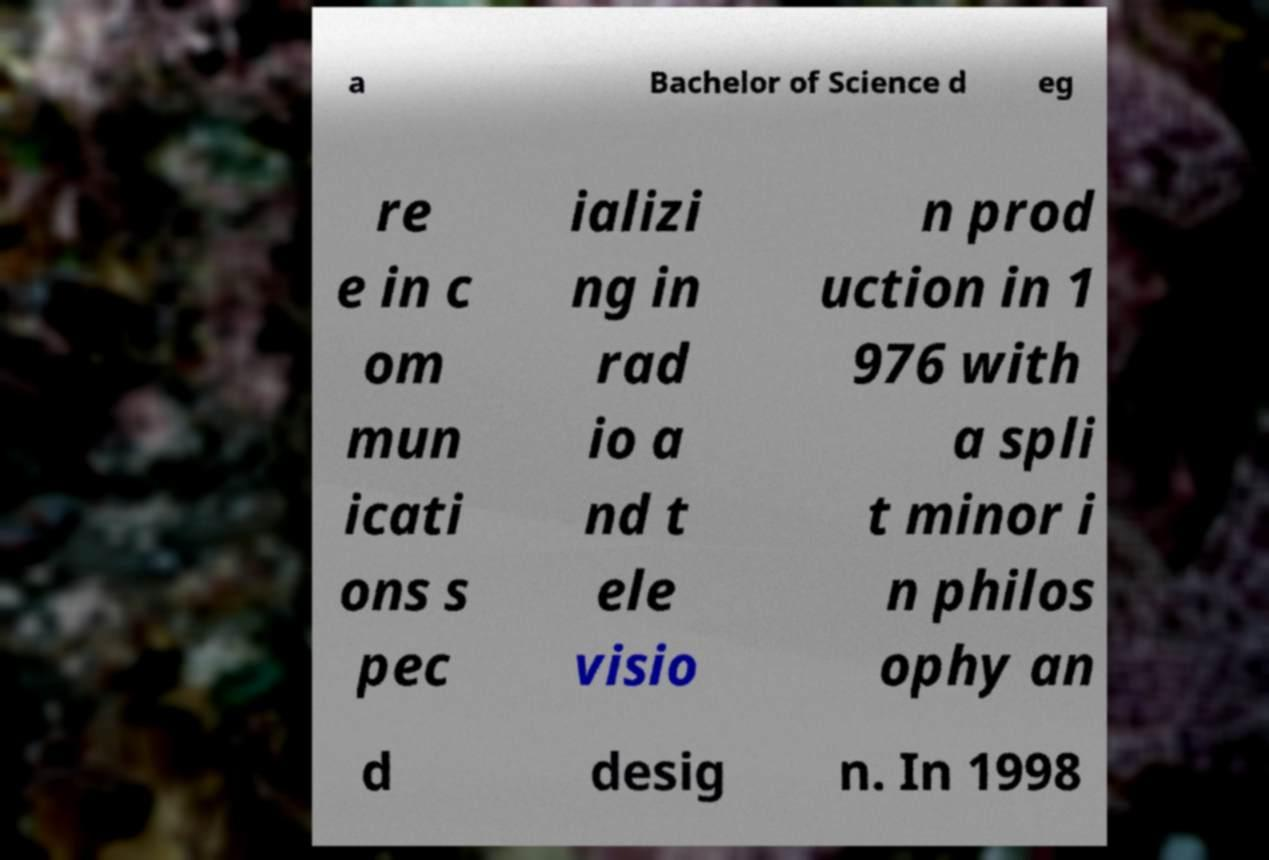Can you read and provide the text displayed in the image?This photo seems to have some interesting text. Can you extract and type it out for me? a Bachelor of Science d eg re e in c om mun icati ons s pec ializi ng in rad io a nd t ele visio n prod uction in 1 976 with a spli t minor i n philos ophy an d desig n. In 1998 